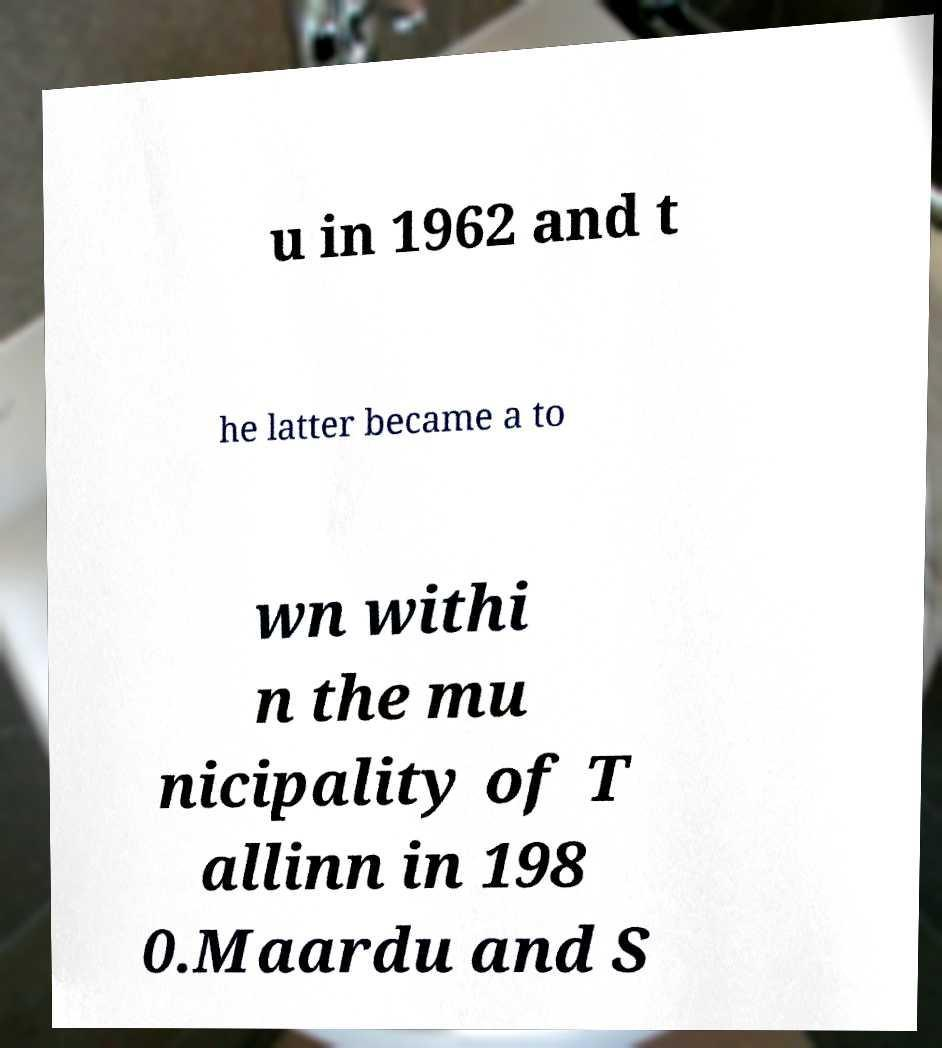Can you accurately transcribe the text from the provided image for me? u in 1962 and t he latter became a to wn withi n the mu nicipality of T allinn in 198 0.Maardu and S 